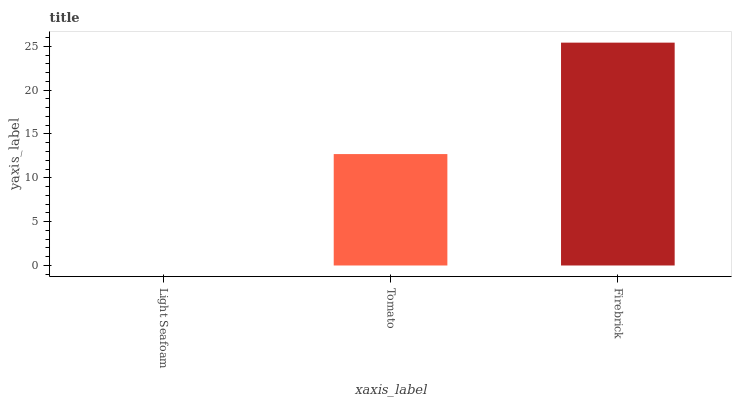Is Light Seafoam the minimum?
Answer yes or no. Yes. Is Firebrick the maximum?
Answer yes or no. Yes. Is Tomato the minimum?
Answer yes or no. No. Is Tomato the maximum?
Answer yes or no. No. Is Tomato greater than Light Seafoam?
Answer yes or no. Yes. Is Light Seafoam less than Tomato?
Answer yes or no. Yes. Is Light Seafoam greater than Tomato?
Answer yes or no. No. Is Tomato less than Light Seafoam?
Answer yes or no. No. Is Tomato the high median?
Answer yes or no. Yes. Is Tomato the low median?
Answer yes or no. Yes. Is Light Seafoam the high median?
Answer yes or no. No. Is Light Seafoam the low median?
Answer yes or no. No. 